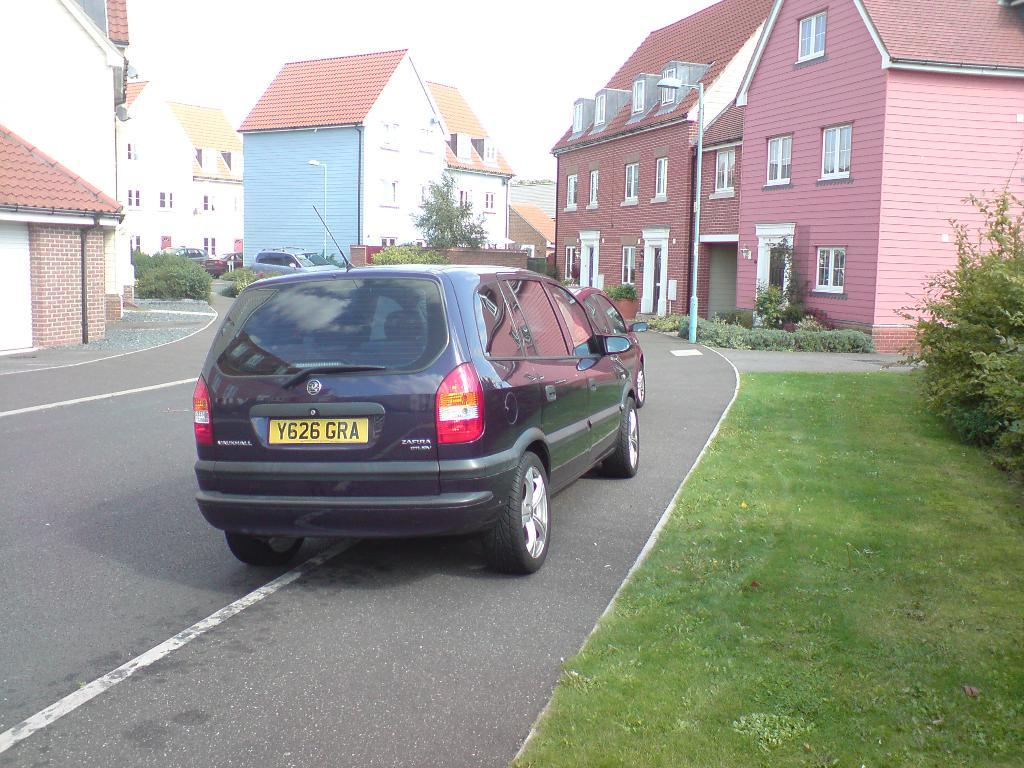Provide a one-sentence caption for the provided image. a car that has GRA written on the back. 